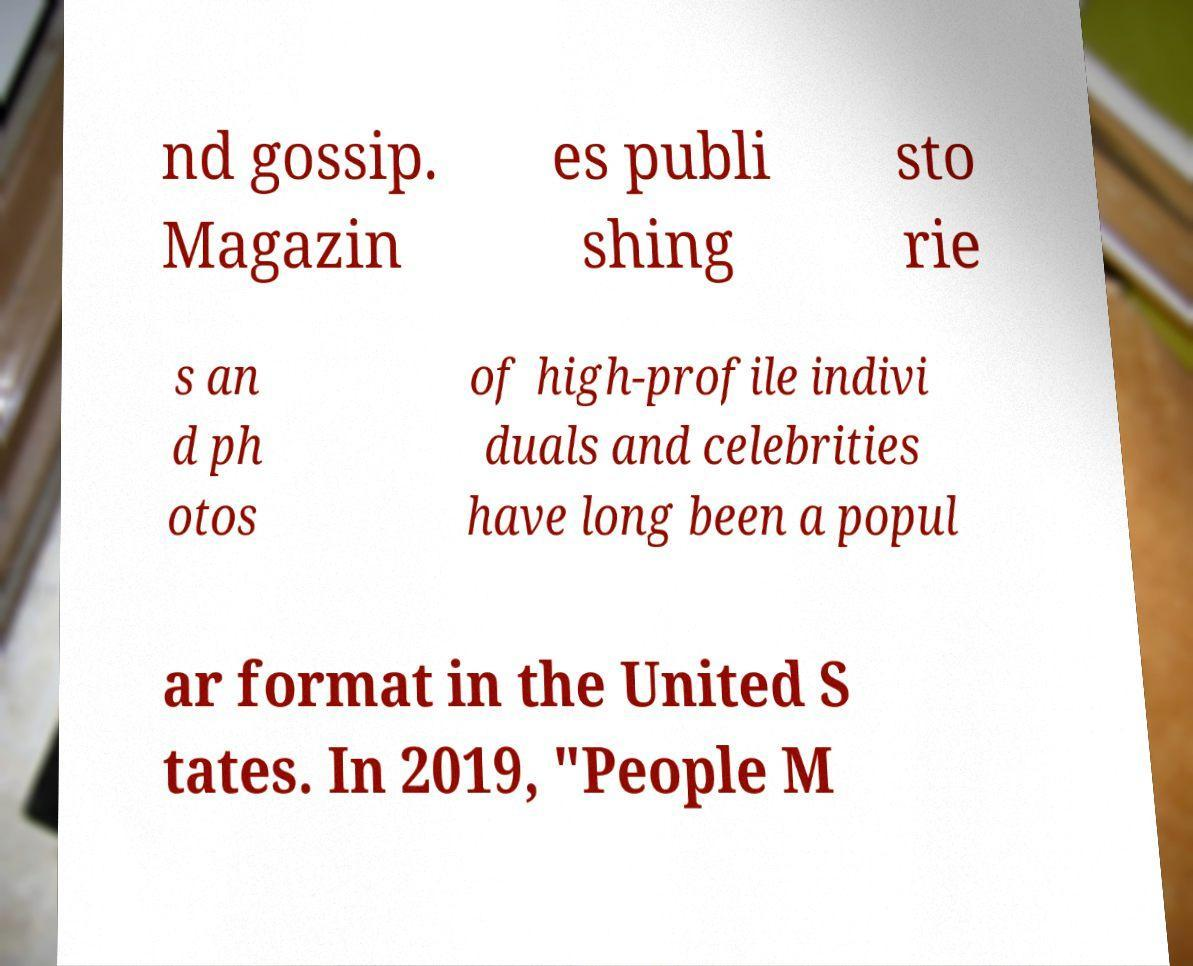Can you read and provide the text displayed in the image?This photo seems to have some interesting text. Can you extract and type it out for me? nd gossip. Magazin es publi shing sto rie s an d ph otos of high-profile indivi duals and celebrities have long been a popul ar format in the United S tates. In 2019, "People M 